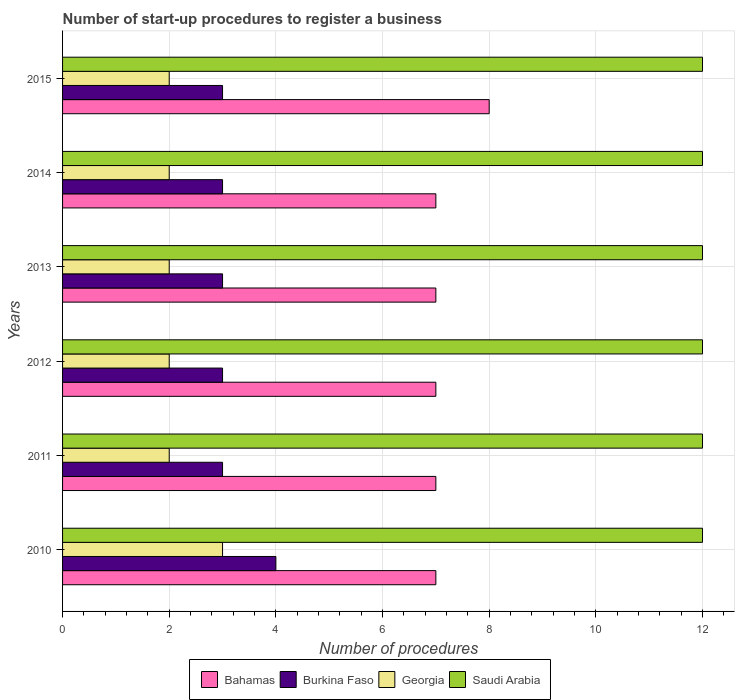How many different coloured bars are there?
Your answer should be compact. 4. How many groups of bars are there?
Make the answer very short. 6. Are the number of bars per tick equal to the number of legend labels?
Keep it short and to the point. Yes. Are the number of bars on each tick of the Y-axis equal?
Keep it short and to the point. Yes. How many bars are there on the 2nd tick from the top?
Provide a succinct answer. 4. How many bars are there on the 4th tick from the bottom?
Provide a succinct answer. 4. What is the label of the 2nd group of bars from the top?
Ensure brevity in your answer.  2014. What is the number of procedures required to register a business in Saudi Arabia in 2015?
Ensure brevity in your answer.  12. Across all years, what is the maximum number of procedures required to register a business in Saudi Arabia?
Offer a very short reply. 12. Across all years, what is the minimum number of procedures required to register a business in Georgia?
Ensure brevity in your answer.  2. What is the total number of procedures required to register a business in Georgia in the graph?
Your answer should be very brief. 13. What is the average number of procedures required to register a business in Saudi Arabia per year?
Ensure brevity in your answer.  12. In the year 2013, what is the difference between the number of procedures required to register a business in Saudi Arabia and number of procedures required to register a business in Burkina Faso?
Your response must be concise. 9. What is the ratio of the number of procedures required to register a business in Georgia in 2010 to that in 2015?
Ensure brevity in your answer.  1.5. Is the number of procedures required to register a business in Burkina Faso in 2013 less than that in 2014?
Offer a very short reply. No. What is the difference between the highest and the second highest number of procedures required to register a business in Saudi Arabia?
Make the answer very short. 0. What is the difference between the highest and the lowest number of procedures required to register a business in Georgia?
Offer a terse response. 1. In how many years, is the number of procedures required to register a business in Saudi Arabia greater than the average number of procedures required to register a business in Saudi Arabia taken over all years?
Provide a short and direct response. 0. Is the sum of the number of procedures required to register a business in Saudi Arabia in 2012 and 2015 greater than the maximum number of procedures required to register a business in Bahamas across all years?
Ensure brevity in your answer.  Yes. Is it the case that in every year, the sum of the number of procedures required to register a business in Bahamas and number of procedures required to register a business in Georgia is greater than the sum of number of procedures required to register a business in Saudi Arabia and number of procedures required to register a business in Burkina Faso?
Keep it short and to the point. Yes. What does the 1st bar from the top in 2012 represents?
Offer a terse response. Saudi Arabia. What does the 1st bar from the bottom in 2012 represents?
Your answer should be compact. Bahamas. How many bars are there?
Your answer should be compact. 24. What is the difference between two consecutive major ticks on the X-axis?
Ensure brevity in your answer.  2. Are the values on the major ticks of X-axis written in scientific E-notation?
Ensure brevity in your answer.  No. Does the graph contain grids?
Provide a short and direct response. Yes. Where does the legend appear in the graph?
Keep it short and to the point. Bottom center. What is the title of the graph?
Give a very brief answer. Number of start-up procedures to register a business. Does "Albania" appear as one of the legend labels in the graph?
Provide a short and direct response. No. What is the label or title of the X-axis?
Provide a short and direct response. Number of procedures. What is the label or title of the Y-axis?
Your response must be concise. Years. What is the Number of procedures of Bahamas in 2010?
Your response must be concise. 7. What is the Number of procedures in Burkina Faso in 2010?
Ensure brevity in your answer.  4. What is the Number of procedures of Georgia in 2010?
Make the answer very short. 3. What is the Number of procedures in Saudi Arabia in 2011?
Ensure brevity in your answer.  12. What is the Number of procedures in Bahamas in 2012?
Offer a very short reply. 7. What is the Number of procedures of Georgia in 2012?
Ensure brevity in your answer.  2. What is the Number of procedures of Bahamas in 2013?
Your answer should be compact. 7. What is the Number of procedures of Burkina Faso in 2013?
Your answer should be very brief. 3. What is the Number of procedures of Saudi Arabia in 2013?
Your answer should be compact. 12. What is the Number of procedures of Bahamas in 2015?
Offer a very short reply. 8. What is the Number of procedures in Burkina Faso in 2015?
Your response must be concise. 3. What is the Number of procedures in Georgia in 2015?
Provide a succinct answer. 2. Across all years, what is the maximum Number of procedures in Bahamas?
Ensure brevity in your answer.  8. Across all years, what is the maximum Number of procedures in Georgia?
Offer a very short reply. 3. Across all years, what is the maximum Number of procedures of Saudi Arabia?
Your answer should be very brief. 12. What is the total Number of procedures of Bahamas in the graph?
Ensure brevity in your answer.  43. What is the difference between the Number of procedures in Georgia in 2010 and that in 2011?
Make the answer very short. 1. What is the difference between the Number of procedures in Georgia in 2010 and that in 2012?
Offer a very short reply. 1. What is the difference between the Number of procedures in Bahamas in 2010 and that in 2013?
Ensure brevity in your answer.  0. What is the difference between the Number of procedures in Burkina Faso in 2010 and that in 2013?
Your answer should be compact. 1. What is the difference between the Number of procedures of Georgia in 2010 and that in 2013?
Offer a terse response. 1. What is the difference between the Number of procedures of Saudi Arabia in 2010 and that in 2013?
Your answer should be compact. 0. What is the difference between the Number of procedures in Bahamas in 2010 and that in 2014?
Your answer should be compact. 0. What is the difference between the Number of procedures in Bahamas in 2010 and that in 2015?
Offer a very short reply. -1. What is the difference between the Number of procedures in Burkina Faso in 2010 and that in 2015?
Provide a succinct answer. 1. What is the difference between the Number of procedures of Georgia in 2011 and that in 2012?
Your answer should be very brief. 0. What is the difference between the Number of procedures in Saudi Arabia in 2011 and that in 2012?
Your answer should be compact. 0. What is the difference between the Number of procedures of Burkina Faso in 2011 and that in 2013?
Provide a short and direct response. 0. What is the difference between the Number of procedures in Bahamas in 2011 and that in 2014?
Offer a very short reply. 0. What is the difference between the Number of procedures in Georgia in 2011 and that in 2014?
Give a very brief answer. 0. What is the difference between the Number of procedures of Saudi Arabia in 2011 and that in 2014?
Your answer should be compact. 0. What is the difference between the Number of procedures in Burkina Faso in 2011 and that in 2015?
Make the answer very short. 0. What is the difference between the Number of procedures of Georgia in 2011 and that in 2015?
Your answer should be compact. 0. What is the difference between the Number of procedures in Saudi Arabia in 2011 and that in 2015?
Offer a very short reply. 0. What is the difference between the Number of procedures of Bahamas in 2012 and that in 2013?
Your answer should be compact. 0. What is the difference between the Number of procedures in Georgia in 2012 and that in 2013?
Ensure brevity in your answer.  0. What is the difference between the Number of procedures in Saudi Arabia in 2012 and that in 2013?
Offer a terse response. 0. What is the difference between the Number of procedures of Georgia in 2012 and that in 2014?
Provide a succinct answer. 0. What is the difference between the Number of procedures of Saudi Arabia in 2012 and that in 2014?
Offer a very short reply. 0. What is the difference between the Number of procedures of Burkina Faso in 2012 and that in 2015?
Offer a terse response. 0. What is the difference between the Number of procedures of Bahamas in 2013 and that in 2014?
Your answer should be very brief. 0. What is the difference between the Number of procedures of Saudi Arabia in 2013 and that in 2014?
Give a very brief answer. 0. What is the difference between the Number of procedures in Georgia in 2013 and that in 2015?
Ensure brevity in your answer.  0. What is the difference between the Number of procedures in Saudi Arabia in 2013 and that in 2015?
Offer a very short reply. 0. What is the difference between the Number of procedures of Burkina Faso in 2014 and that in 2015?
Provide a short and direct response. 0. What is the difference between the Number of procedures of Saudi Arabia in 2014 and that in 2015?
Offer a terse response. 0. What is the difference between the Number of procedures of Bahamas in 2010 and the Number of procedures of Burkina Faso in 2011?
Make the answer very short. 4. What is the difference between the Number of procedures in Bahamas in 2010 and the Number of procedures in Georgia in 2011?
Offer a very short reply. 5. What is the difference between the Number of procedures in Bahamas in 2010 and the Number of procedures in Saudi Arabia in 2011?
Your response must be concise. -5. What is the difference between the Number of procedures of Burkina Faso in 2010 and the Number of procedures of Georgia in 2011?
Your answer should be compact. 2. What is the difference between the Number of procedures in Georgia in 2010 and the Number of procedures in Saudi Arabia in 2011?
Provide a succinct answer. -9. What is the difference between the Number of procedures in Bahamas in 2010 and the Number of procedures in Georgia in 2012?
Keep it short and to the point. 5. What is the difference between the Number of procedures in Burkina Faso in 2010 and the Number of procedures in Saudi Arabia in 2012?
Your answer should be very brief. -8. What is the difference between the Number of procedures of Bahamas in 2010 and the Number of procedures of Georgia in 2013?
Ensure brevity in your answer.  5. What is the difference between the Number of procedures of Bahamas in 2010 and the Number of procedures of Saudi Arabia in 2013?
Your answer should be very brief. -5. What is the difference between the Number of procedures in Burkina Faso in 2010 and the Number of procedures in Georgia in 2013?
Give a very brief answer. 2. What is the difference between the Number of procedures of Burkina Faso in 2010 and the Number of procedures of Saudi Arabia in 2013?
Your answer should be compact. -8. What is the difference between the Number of procedures in Bahamas in 2010 and the Number of procedures in Georgia in 2014?
Keep it short and to the point. 5. What is the difference between the Number of procedures in Bahamas in 2010 and the Number of procedures in Saudi Arabia in 2014?
Provide a short and direct response. -5. What is the difference between the Number of procedures in Burkina Faso in 2010 and the Number of procedures in Georgia in 2014?
Provide a succinct answer. 2. What is the difference between the Number of procedures of Burkina Faso in 2010 and the Number of procedures of Saudi Arabia in 2014?
Ensure brevity in your answer.  -8. What is the difference between the Number of procedures of Georgia in 2010 and the Number of procedures of Saudi Arabia in 2014?
Keep it short and to the point. -9. What is the difference between the Number of procedures in Bahamas in 2010 and the Number of procedures in Saudi Arabia in 2015?
Your answer should be very brief. -5. What is the difference between the Number of procedures of Burkina Faso in 2010 and the Number of procedures of Georgia in 2015?
Your answer should be very brief. 2. What is the difference between the Number of procedures of Burkina Faso in 2010 and the Number of procedures of Saudi Arabia in 2015?
Offer a very short reply. -8. What is the difference between the Number of procedures of Georgia in 2010 and the Number of procedures of Saudi Arabia in 2015?
Provide a short and direct response. -9. What is the difference between the Number of procedures in Bahamas in 2011 and the Number of procedures in Burkina Faso in 2012?
Provide a short and direct response. 4. What is the difference between the Number of procedures of Bahamas in 2011 and the Number of procedures of Georgia in 2012?
Provide a short and direct response. 5. What is the difference between the Number of procedures of Bahamas in 2011 and the Number of procedures of Georgia in 2013?
Keep it short and to the point. 5. What is the difference between the Number of procedures in Bahamas in 2011 and the Number of procedures in Saudi Arabia in 2013?
Provide a succinct answer. -5. What is the difference between the Number of procedures of Burkina Faso in 2011 and the Number of procedures of Georgia in 2013?
Your answer should be very brief. 1. What is the difference between the Number of procedures in Burkina Faso in 2011 and the Number of procedures in Saudi Arabia in 2013?
Offer a terse response. -9. What is the difference between the Number of procedures of Georgia in 2011 and the Number of procedures of Saudi Arabia in 2013?
Your answer should be very brief. -10. What is the difference between the Number of procedures of Bahamas in 2011 and the Number of procedures of Burkina Faso in 2014?
Offer a terse response. 4. What is the difference between the Number of procedures of Burkina Faso in 2011 and the Number of procedures of Saudi Arabia in 2014?
Provide a short and direct response. -9. What is the difference between the Number of procedures in Bahamas in 2011 and the Number of procedures in Saudi Arabia in 2015?
Offer a very short reply. -5. What is the difference between the Number of procedures in Burkina Faso in 2011 and the Number of procedures in Saudi Arabia in 2015?
Offer a terse response. -9. What is the difference between the Number of procedures in Bahamas in 2012 and the Number of procedures in Georgia in 2013?
Your answer should be very brief. 5. What is the difference between the Number of procedures in Burkina Faso in 2012 and the Number of procedures in Georgia in 2013?
Your response must be concise. 1. What is the difference between the Number of procedures in Burkina Faso in 2012 and the Number of procedures in Saudi Arabia in 2013?
Ensure brevity in your answer.  -9. What is the difference between the Number of procedures of Georgia in 2012 and the Number of procedures of Saudi Arabia in 2013?
Keep it short and to the point. -10. What is the difference between the Number of procedures in Bahamas in 2012 and the Number of procedures in Burkina Faso in 2014?
Your answer should be very brief. 4. What is the difference between the Number of procedures in Burkina Faso in 2012 and the Number of procedures in Georgia in 2014?
Give a very brief answer. 1. What is the difference between the Number of procedures of Bahamas in 2012 and the Number of procedures of Saudi Arabia in 2015?
Ensure brevity in your answer.  -5. What is the difference between the Number of procedures of Georgia in 2012 and the Number of procedures of Saudi Arabia in 2015?
Ensure brevity in your answer.  -10. What is the difference between the Number of procedures of Bahamas in 2013 and the Number of procedures of Burkina Faso in 2014?
Your answer should be very brief. 4. What is the difference between the Number of procedures of Bahamas in 2013 and the Number of procedures of Georgia in 2014?
Provide a short and direct response. 5. What is the difference between the Number of procedures in Burkina Faso in 2013 and the Number of procedures in Georgia in 2014?
Make the answer very short. 1. What is the difference between the Number of procedures of Burkina Faso in 2013 and the Number of procedures of Saudi Arabia in 2014?
Keep it short and to the point. -9. What is the difference between the Number of procedures in Bahamas in 2013 and the Number of procedures in Burkina Faso in 2015?
Keep it short and to the point. 4. What is the difference between the Number of procedures of Burkina Faso in 2013 and the Number of procedures of Saudi Arabia in 2015?
Your answer should be very brief. -9. What is the difference between the Number of procedures of Bahamas in 2014 and the Number of procedures of Burkina Faso in 2015?
Make the answer very short. 4. What is the difference between the Number of procedures in Bahamas in 2014 and the Number of procedures in Georgia in 2015?
Offer a very short reply. 5. What is the difference between the Number of procedures in Burkina Faso in 2014 and the Number of procedures in Georgia in 2015?
Provide a short and direct response. 1. What is the average Number of procedures of Bahamas per year?
Your answer should be compact. 7.17. What is the average Number of procedures in Burkina Faso per year?
Your answer should be compact. 3.17. What is the average Number of procedures of Georgia per year?
Your answer should be compact. 2.17. What is the average Number of procedures of Saudi Arabia per year?
Offer a very short reply. 12. In the year 2010, what is the difference between the Number of procedures of Burkina Faso and Number of procedures of Georgia?
Keep it short and to the point. 1. In the year 2010, what is the difference between the Number of procedures in Burkina Faso and Number of procedures in Saudi Arabia?
Ensure brevity in your answer.  -8. In the year 2010, what is the difference between the Number of procedures in Georgia and Number of procedures in Saudi Arabia?
Your response must be concise. -9. In the year 2011, what is the difference between the Number of procedures of Burkina Faso and Number of procedures of Saudi Arabia?
Provide a succinct answer. -9. In the year 2012, what is the difference between the Number of procedures of Bahamas and Number of procedures of Burkina Faso?
Give a very brief answer. 4. In the year 2012, what is the difference between the Number of procedures of Burkina Faso and Number of procedures of Georgia?
Offer a terse response. 1. In the year 2013, what is the difference between the Number of procedures in Bahamas and Number of procedures in Burkina Faso?
Your response must be concise. 4. In the year 2013, what is the difference between the Number of procedures of Bahamas and Number of procedures of Georgia?
Offer a terse response. 5. In the year 2013, what is the difference between the Number of procedures of Bahamas and Number of procedures of Saudi Arabia?
Give a very brief answer. -5. In the year 2013, what is the difference between the Number of procedures of Burkina Faso and Number of procedures of Georgia?
Your response must be concise. 1. In the year 2013, what is the difference between the Number of procedures of Burkina Faso and Number of procedures of Saudi Arabia?
Provide a succinct answer. -9. In the year 2013, what is the difference between the Number of procedures in Georgia and Number of procedures in Saudi Arabia?
Offer a very short reply. -10. In the year 2014, what is the difference between the Number of procedures in Bahamas and Number of procedures in Saudi Arabia?
Keep it short and to the point. -5. In the year 2014, what is the difference between the Number of procedures of Burkina Faso and Number of procedures of Saudi Arabia?
Provide a succinct answer. -9. In the year 2015, what is the difference between the Number of procedures of Bahamas and Number of procedures of Burkina Faso?
Provide a short and direct response. 5. In the year 2015, what is the difference between the Number of procedures in Bahamas and Number of procedures in Saudi Arabia?
Provide a succinct answer. -4. What is the ratio of the Number of procedures of Bahamas in 2010 to that in 2011?
Your response must be concise. 1. What is the ratio of the Number of procedures in Bahamas in 2010 to that in 2012?
Offer a very short reply. 1. What is the ratio of the Number of procedures of Georgia in 2010 to that in 2012?
Ensure brevity in your answer.  1.5. What is the ratio of the Number of procedures of Bahamas in 2010 to that in 2013?
Provide a succinct answer. 1. What is the ratio of the Number of procedures in Burkina Faso in 2010 to that in 2013?
Offer a very short reply. 1.33. What is the ratio of the Number of procedures in Georgia in 2010 to that in 2013?
Give a very brief answer. 1.5. What is the ratio of the Number of procedures in Saudi Arabia in 2010 to that in 2013?
Offer a very short reply. 1. What is the ratio of the Number of procedures in Bahamas in 2010 to that in 2014?
Provide a short and direct response. 1. What is the ratio of the Number of procedures in Burkina Faso in 2010 to that in 2014?
Your response must be concise. 1.33. What is the ratio of the Number of procedures in Georgia in 2010 to that in 2014?
Your answer should be very brief. 1.5. What is the ratio of the Number of procedures in Bahamas in 2010 to that in 2015?
Provide a short and direct response. 0.88. What is the ratio of the Number of procedures in Burkina Faso in 2010 to that in 2015?
Provide a succinct answer. 1.33. What is the ratio of the Number of procedures in Burkina Faso in 2011 to that in 2012?
Offer a terse response. 1. What is the ratio of the Number of procedures of Saudi Arabia in 2011 to that in 2012?
Your response must be concise. 1. What is the ratio of the Number of procedures of Bahamas in 2011 to that in 2013?
Give a very brief answer. 1. What is the ratio of the Number of procedures in Burkina Faso in 2011 to that in 2013?
Offer a terse response. 1. What is the ratio of the Number of procedures of Saudi Arabia in 2011 to that in 2013?
Provide a short and direct response. 1. What is the ratio of the Number of procedures in Bahamas in 2011 to that in 2014?
Offer a terse response. 1. What is the ratio of the Number of procedures of Burkina Faso in 2011 to that in 2014?
Make the answer very short. 1. What is the ratio of the Number of procedures in Bahamas in 2011 to that in 2015?
Ensure brevity in your answer.  0.88. What is the ratio of the Number of procedures in Burkina Faso in 2012 to that in 2013?
Offer a very short reply. 1. What is the ratio of the Number of procedures in Saudi Arabia in 2012 to that in 2013?
Your response must be concise. 1. What is the ratio of the Number of procedures of Bahamas in 2012 to that in 2014?
Your response must be concise. 1. What is the ratio of the Number of procedures in Burkina Faso in 2012 to that in 2014?
Ensure brevity in your answer.  1. What is the ratio of the Number of procedures of Georgia in 2012 to that in 2014?
Offer a very short reply. 1. What is the ratio of the Number of procedures of Burkina Faso in 2012 to that in 2015?
Make the answer very short. 1. What is the ratio of the Number of procedures of Georgia in 2012 to that in 2015?
Your answer should be very brief. 1. What is the ratio of the Number of procedures of Bahamas in 2013 to that in 2014?
Give a very brief answer. 1. What is the ratio of the Number of procedures in Burkina Faso in 2013 to that in 2014?
Your answer should be compact. 1. What is the ratio of the Number of procedures in Bahamas in 2013 to that in 2015?
Ensure brevity in your answer.  0.88. What is the ratio of the Number of procedures in Burkina Faso in 2013 to that in 2015?
Offer a terse response. 1. What is the ratio of the Number of procedures in Georgia in 2013 to that in 2015?
Offer a very short reply. 1. What is the ratio of the Number of procedures of Bahamas in 2014 to that in 2015?
Keep it short and to the point. 0.88. What is the difference between the highest and the second highest Number of procedures in Saudi Arabia?
Your answer should be compact. 0. What is the difference between the highest and the lowest Number of procedures in Bahamas?
Keep it short and to the point. 1. What is the difference between the highest and the lowest Number of procedures in Burkina Faso?
Your answer should be compact. 1. 